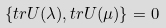<formula> <loc_0><loc_0><loc_500><loc_500>\{ t r U ( \lambda ) , t r U ( \mu ) \} = 0</formula> 